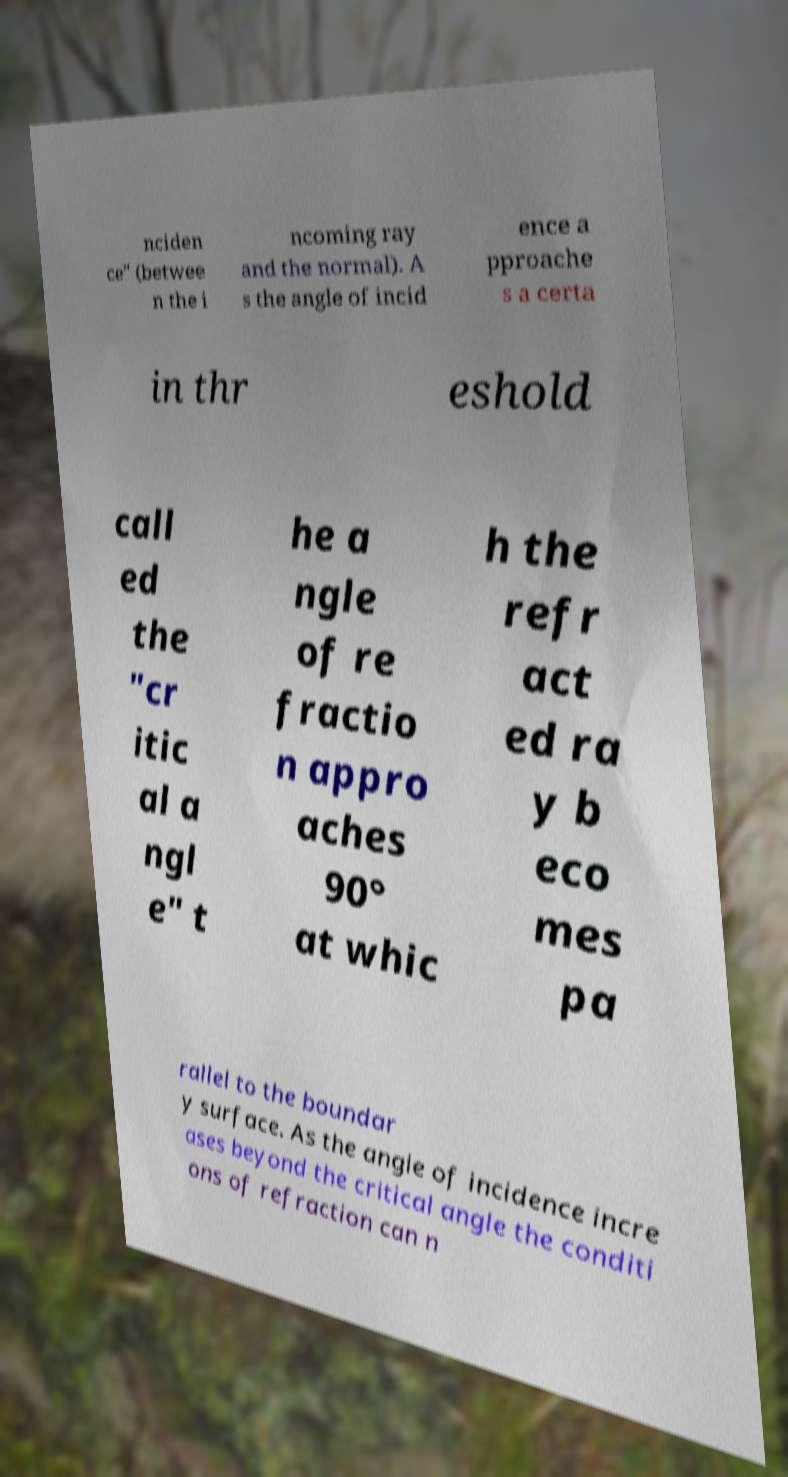Please identify and transcribe the text found in this image. nciden ce" (betwee n the i ncoming ray and the normal). A s the angle of incid ence a pproache s a certa in thr eshold call ed the "cr itic al a ngl e" t he a ngle of re fractio n appro aches 90° at whic h the refr act ed ra y b eco mes pa rallel to the boundar y surface. As the angle of incidence incre ases beyond the critical angle the conditi ons of refraction can n 